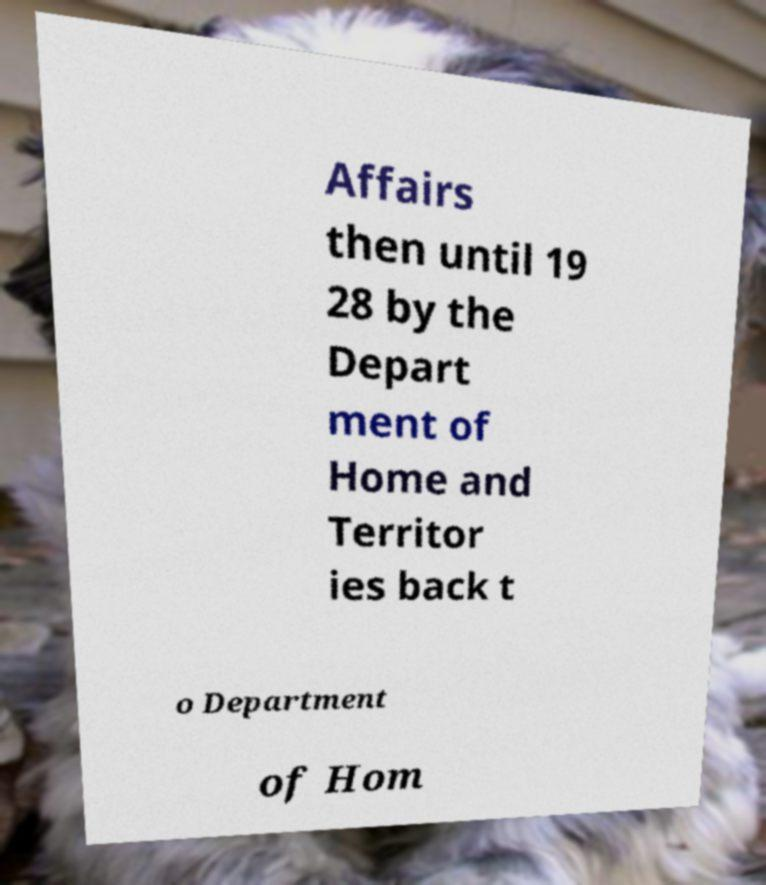Please identify and transcribe the text found in this image. Affairs then until 19 28 by the Depart ment of Home and Territor ies back t o Department of Hom 